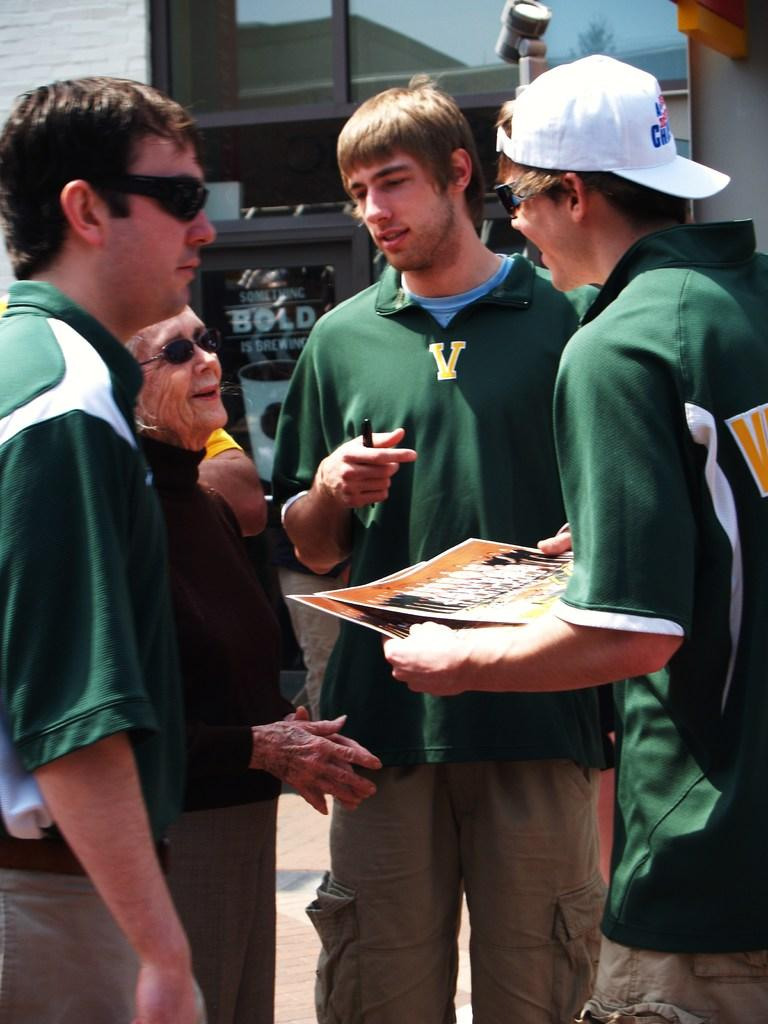What is happening in the image? There are people standing in the image. What is one person holding in his hand? One person is holding photographs in his hand. What can be seen in the distance behind the people? There is a building in the background of the image. What is causing the roll of fabric to move in the image? There is no roll of fabric present in the image. 